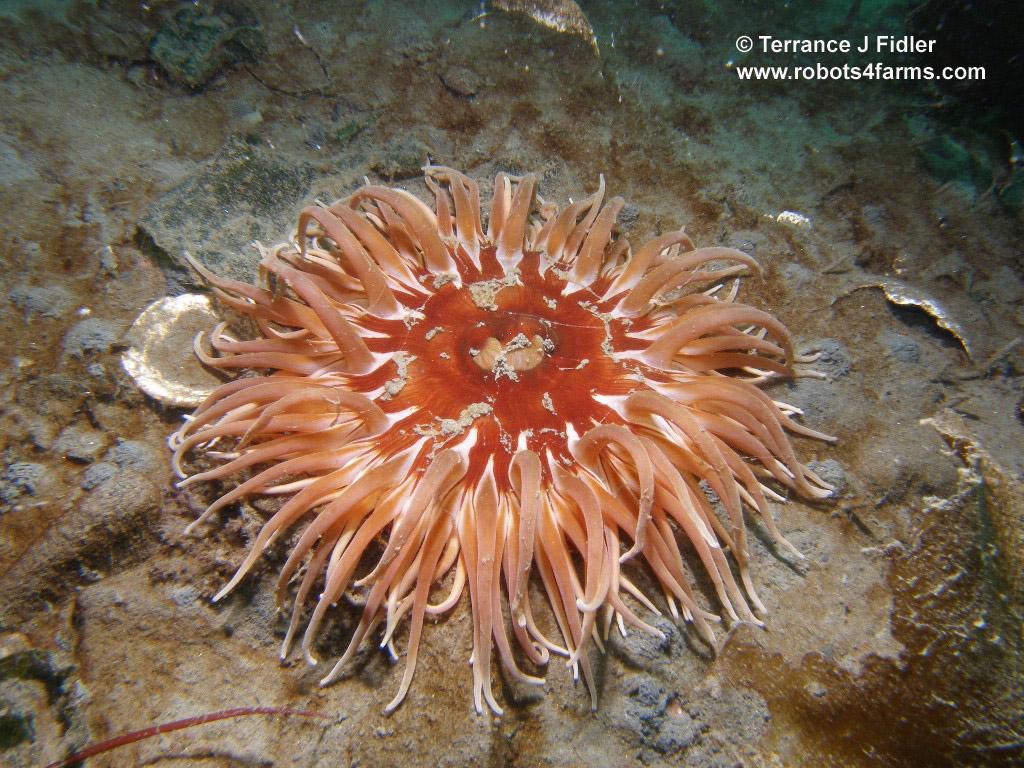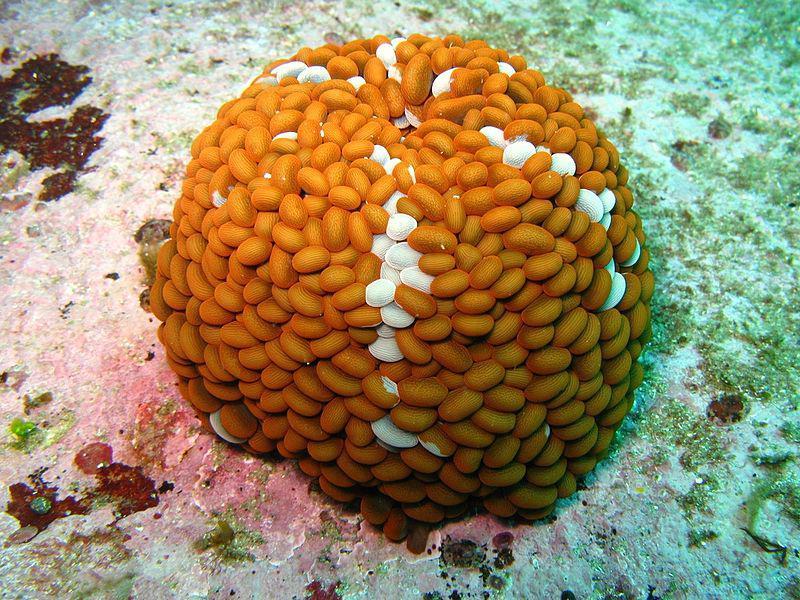The first image is the image on the left, the second image is the image on the right. For the images shown, is this caption "At least one of the organisms is a spherical shape." true? Answer yes or no. Yes. The first image is the image on the left, the second image is the image on the right. For the images displayed, is the sentence "At least one image features several anemone." factually correct? Answer yes or no. No. The first image is the image on the left, the second image is the image on the right. Examine the images to the left and right. Is the description "Each image contains one prominent roundish marine creature, and the image on the left shows an anemone with tapered orangish tendrils radiating from a center." accurate? Answer yes or no. Yes. The first image is the image on the left, the second image is the image on the right. Evaluate the accuracy of this statement regarding the images: "An image includes an anemone with pink tendrils trailing down from a darker stout red stalk.". Is it true? Answer yes or no. No. 